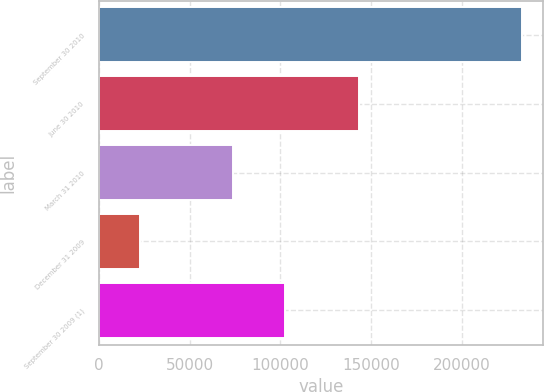<chart> <loc_0><loc_0><loc_500><loc_500><bar_chart><fcel>September 30 2010<fcel>June 30 2010<fcel>March 31 2010<fcel>December 31 2009<fcel>September 30 2009 (1)<nl><fcel>233346<fcel>143163<fcel>73650<fcel>22733<fcel>102758<nl></chart> 